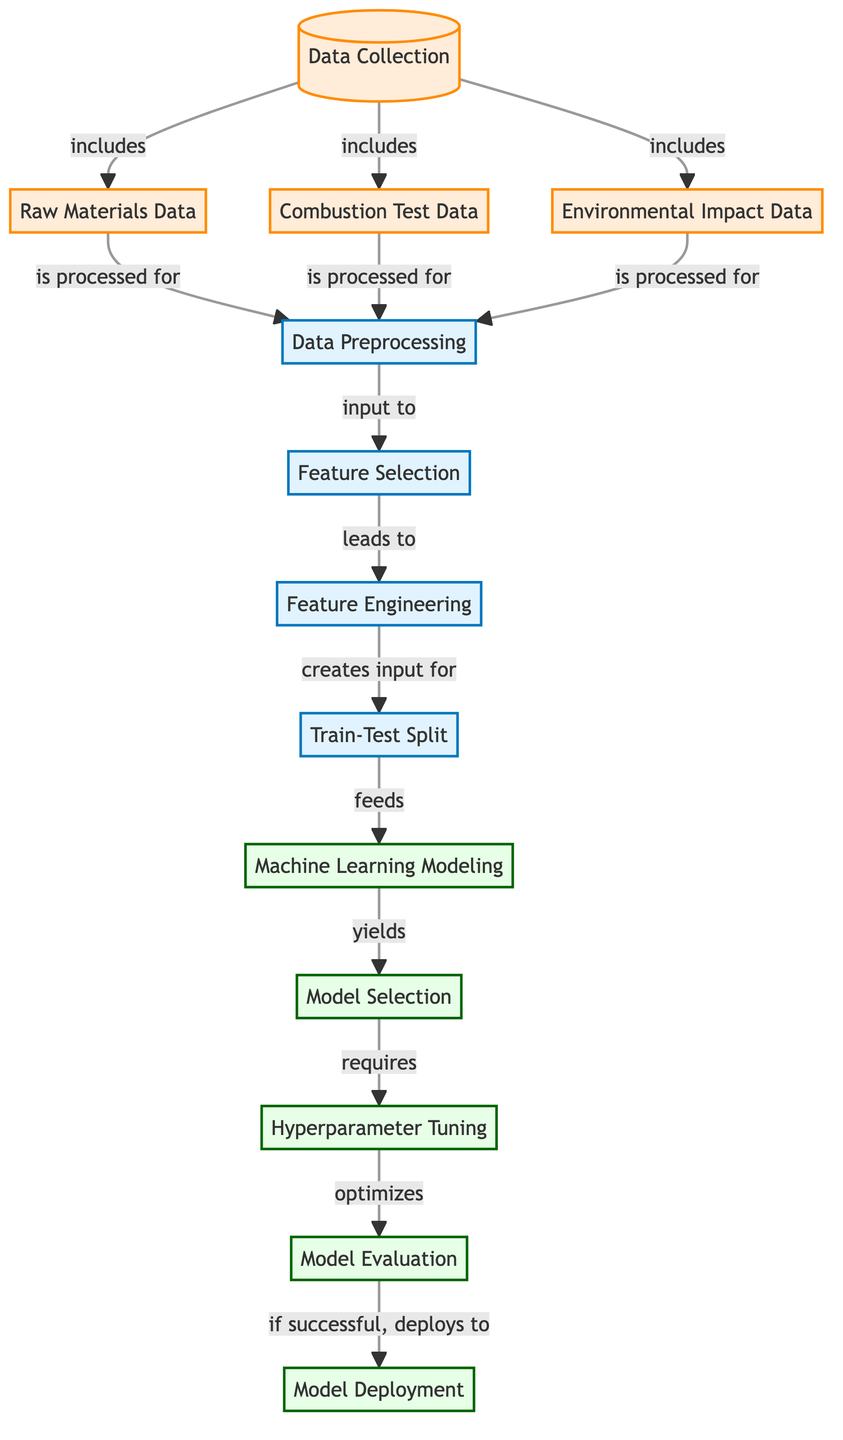What are the three types of data collected in this diagram? The diagram explicitly lists three data types: Raw Materials Data, Combustion Test Data, and Environmental Impact Data under the Data Collection node.
Answer: Raw Materials Data, Combustion Test Data, Environmental Impact Data What is the process that follows Data Preprocessing? After Data Preprocessing, the next step is Feature Selection, as indicated by the arrow leading from Preprocessing to Feature Selection.
Answer: Feature Selection Which node is the final step before Model Deployment? The final step before Model Deployment is Model Evaluation, as it is depicted directly leading to the Deployment node in the diagram.
Answer: Model Evaluation What is the relationship between Feature Engineering and Train-Test Split? Feature Engineering creates input for Train-Test Split, as shown by the directional arrow connecting these two nodes in the diagram.
Answer: creates input for How many processes are identified in the diagram? The diagram identifies five processes: Data Preprocessing, Feature Selection, Feature Engineering, Train-Test Split, and Machine Learning Modeling. Counting these nodes gives us the total number of processes.
Answer: five What is optimized during Hyperparameter Tuning? Hyperparameter Tuning optimizes Model Evaluation, as the arrow indicates that Hyperparameter Tuning affects the outcome of Model Evaluation in the diagram.
Answer: Model Evaluation Which node appears first in the diagram sequence? The first node in the diagram sequence is Data Collection, as it is where the flow begins before moving to the subsequent processes.
Answer: Data Collection Which process leads to Model Selection? The process that leads to Model Selection is Machine Learning Modeling, as shown by the flow arrow pointing from ML Modeling to Model Selection in the diagram.
Answer: Machine Learning Modeling What type of diagram is depicted here? This diagram represents a Machine Learning Diagram illustrating the steps taken to optimize energy yield in sustainable rocket propellants using machine learning processes.
Answer: Machine Learning Diagram 